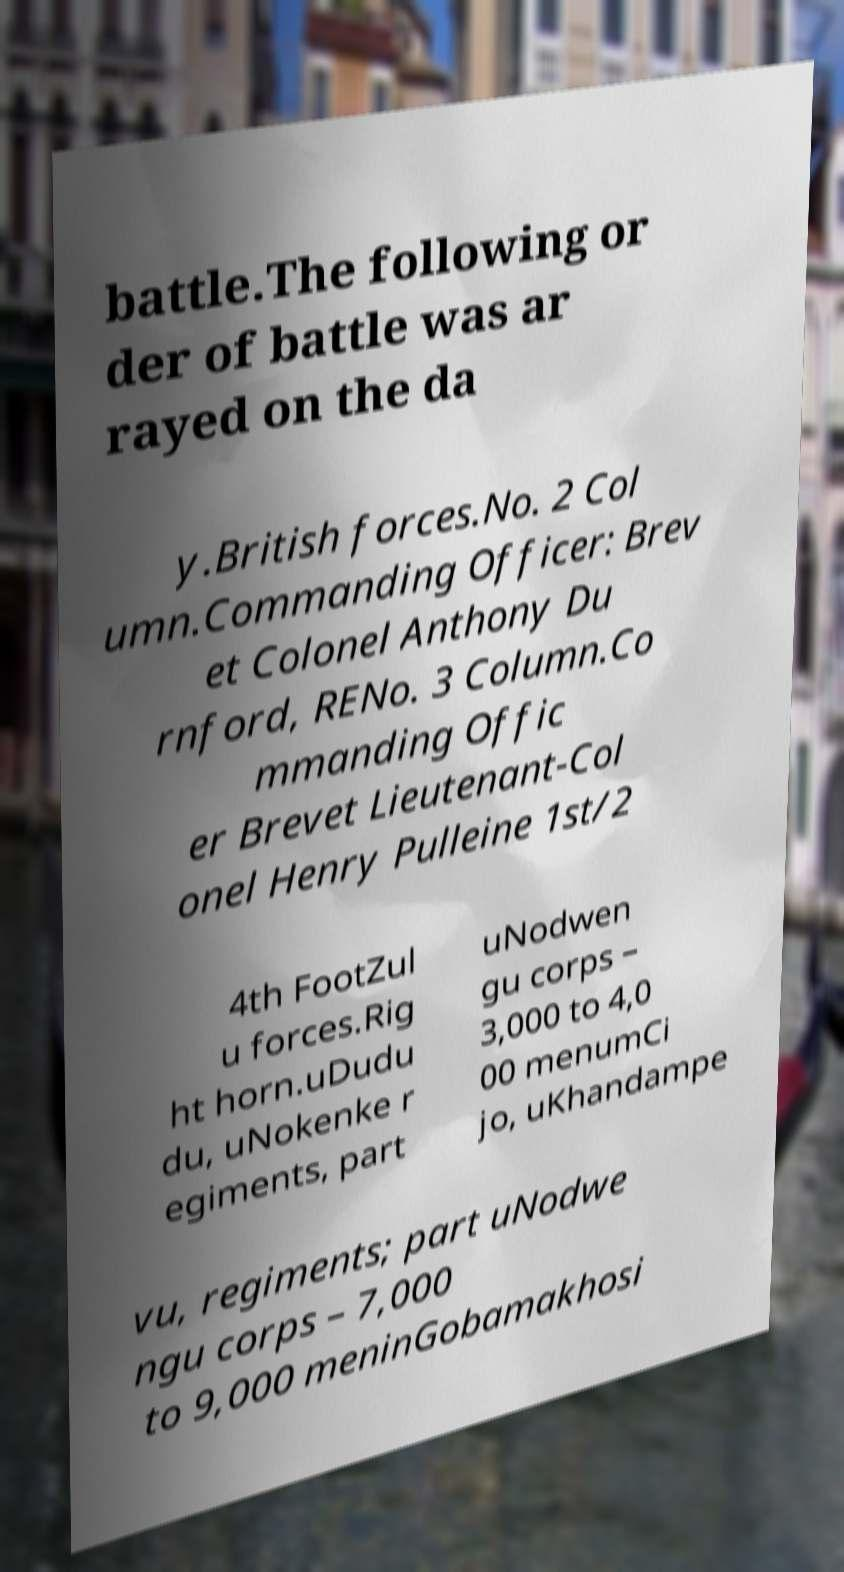Can you read and provide the text displayed in the image?This photo seems to have some interesting text. Can you extract and type it out for me? battle.The following or der of battle was ar rayed on the da y.British forces.No. 2 Col umn.Commanding Officer: Brev et Colonel Anthony Du rnford, RENo. 3 Column.Co mmanding Offic er Brevet Lieutenant-Col onel Henry Pulleine 1st/2 4th FootZul u forces.Rig ht horn.uDudu du, uNokenke r egiments, part uNodwen gu corps – 3,000 to 4,0 00 menumCi jo, uKhandampe vu, regiments; part uNodwe ngu corps – 7,000 to 9,000 meninGobamakhosi 